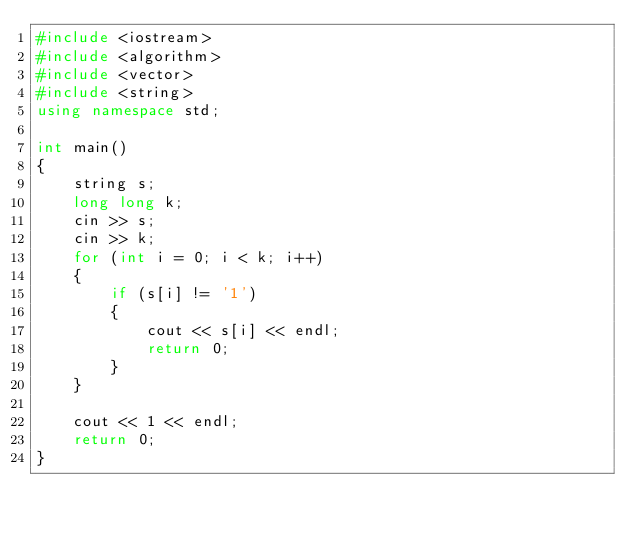<code> <loc_0><loc_0><loc_500><loc_500><_C++_>#include <iostream>
#include <algorithm>
#include <vector>
#include <string>
using namespace std;

int main()
{
	string s;
	long long k;
	cin >> s;
	cin >> k;
	for (int i = 0; i < k; i++)
	{
		if (s[i] != '1')
		{
			cout << s[i] << endl;
			return 0;
		}
	}

	cout << 1 << endl;
    return 0;
}
</code> 